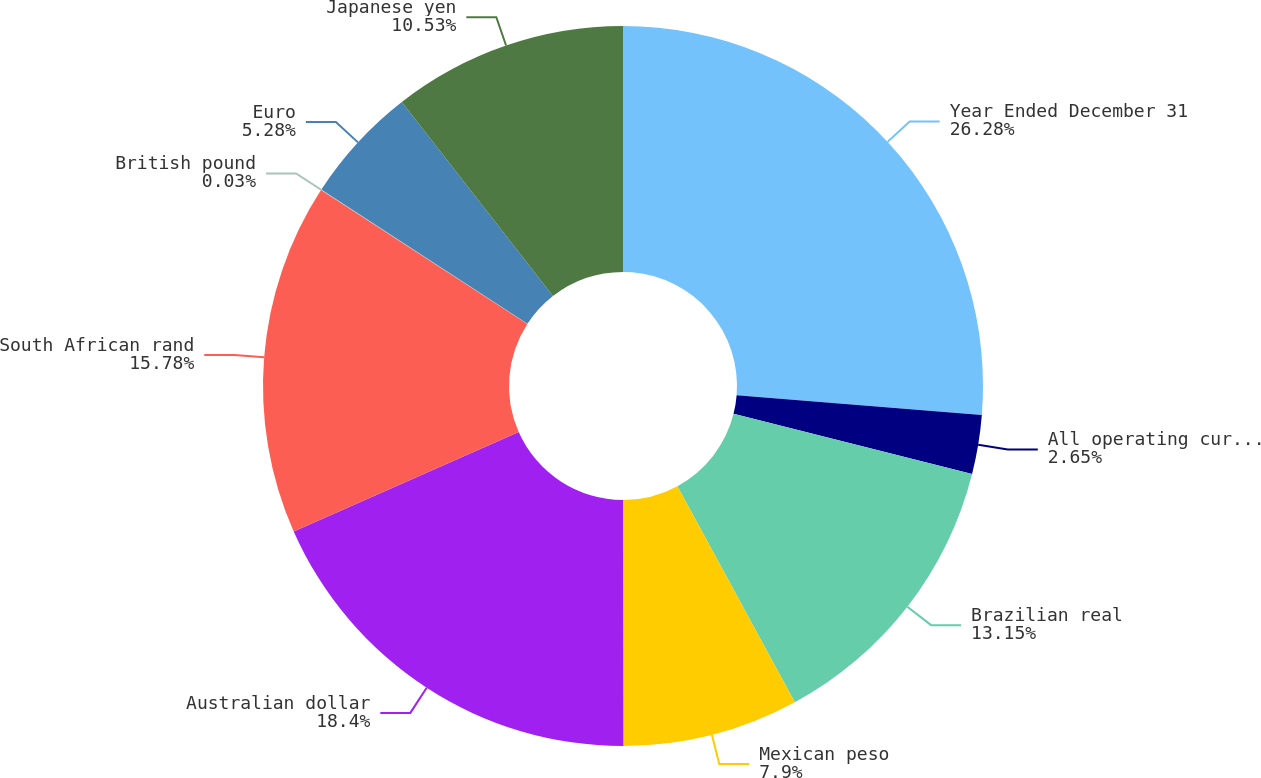Convert chart to OTSL. <chart><loc_0><loc_0><loc_500><loc_500><pie_chart><fcel>Year Ended December 31<fcel>All operating currencies<fcel>Brazilian real<fcel>Mexican peso<fcel>Australian dollar<fcel>South African rand<fcel>British pound<fcel>Euro<fcel>Japanese yen<nl><fcel>26.28%<fcel>2.65%<fcel>13.15%<fcel>7.9%<fcel>18.4%<fcel>15.78%<fcel>0.03%<fcel>5.28%<fcel>10.53%<nl></chart> 